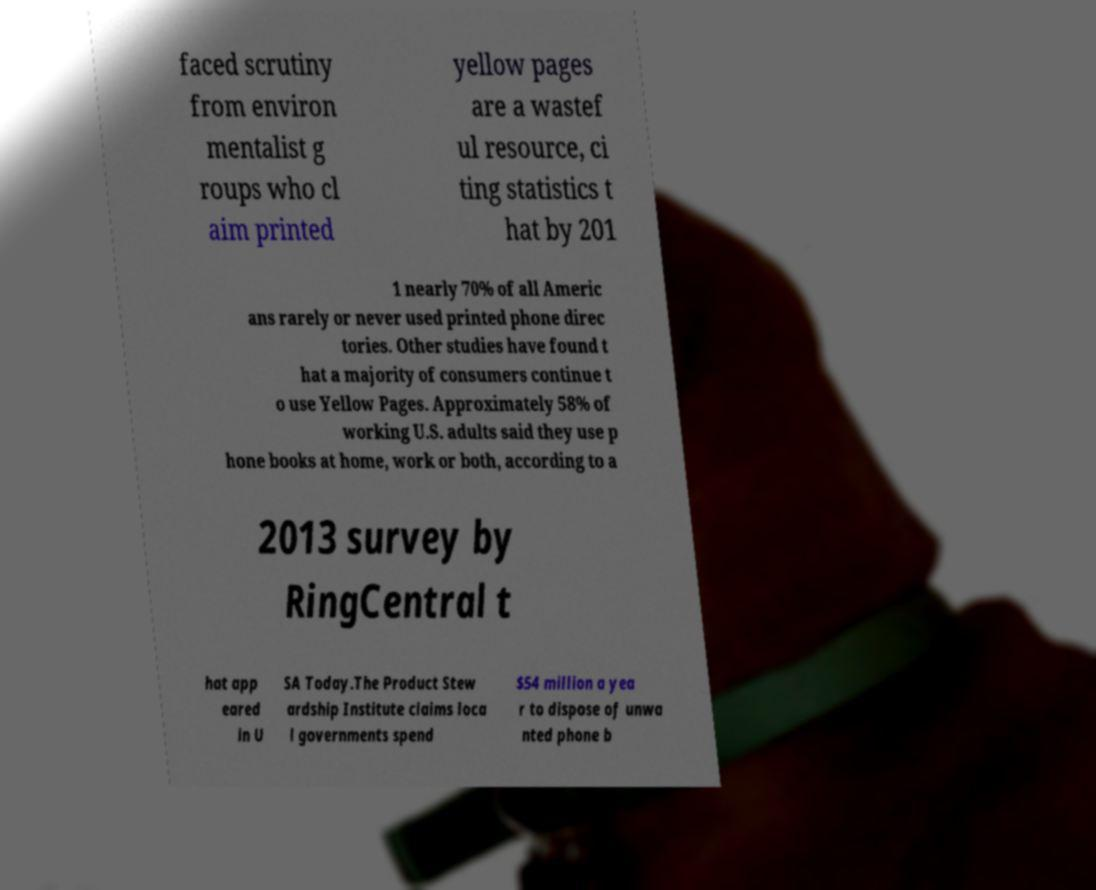I need the written content from this picture converted into text. Can you do that? faced scrutiny from environ mentalist g roups who cl aim printed yellow pages are a wastef ul resource, ci ting statistics t hat by 201 1 nearly 70% of all Americ ans rarely or never used printed phone direc tories. Other studies have found t hat a majority of consumers continue t o use Yellow Pages. Approximately 58% of working U.S. adults said they use p hone books at home, work or both, according to a 2013 survey by RingCentral t hat app eared in U SA Today.The Product Stew ardship Institute claims loca l governments spend $54 million a yea r to dispose of unwa nted phone b 